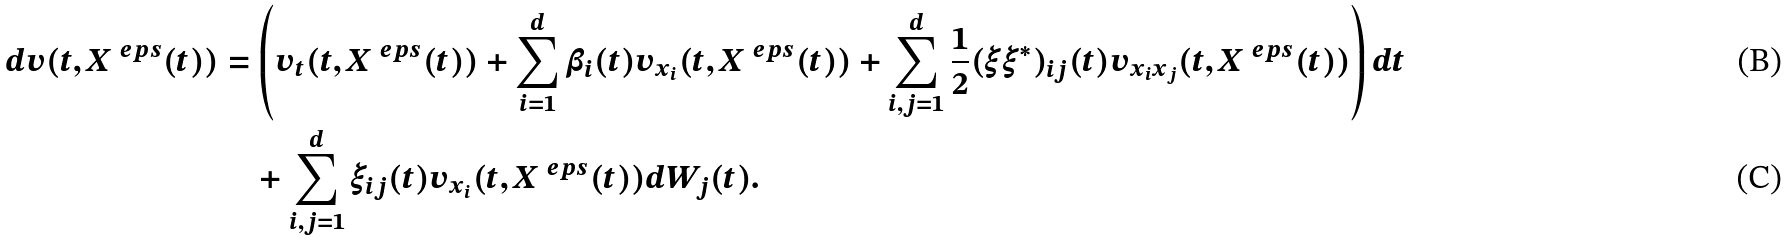Convert formula to latex. <formula><loc_0><loc_0><loc_500><loc_500>d v ( t , X ^ { \ e p s } ( t ) ) & = \left ( v _ { t } ( t , X ^ { \ e p s } ( t ) ) + \sum _ { i = 1 } ^ { d } \beta _ { i } ( t ) v _ { x _ { i } } ( t , X ^ { \ e p s } ( t ) ) + \sum _ { i , j = 1 } ^ { d } \frac { 1 } { 2 } ( \xi \xi ^ { * } ) _ { i j } ( t ) v _ { x _ { i } x _ { j } } ( t , X ^ { \ e p s } ( t ) ) \right ) d t \\ & \quad + \sum _ { i , j = 1 } ^ { d } \xi _ { i j } ( t ) v _ { x _ { i } } ( t , X ^ { \ e p s } ( t ) ) d W _ { j } ( t ) .</formula> 